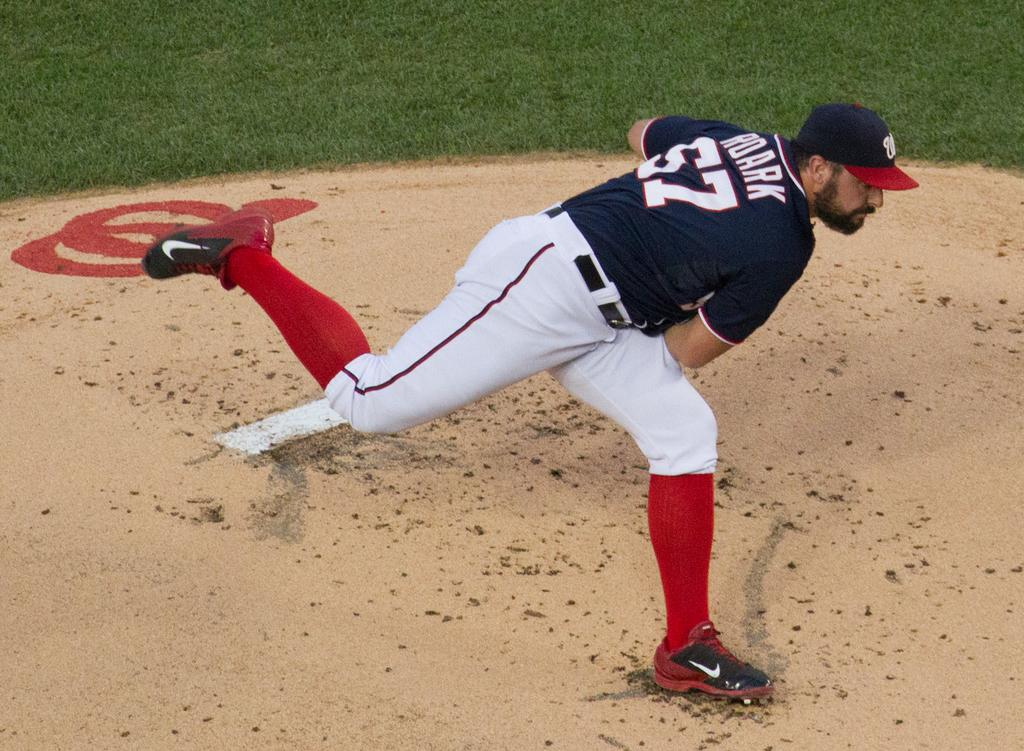Provide a one-sentence caption for the provided image. A pitcher that has the name Roark and the number 57 on his shirt. 